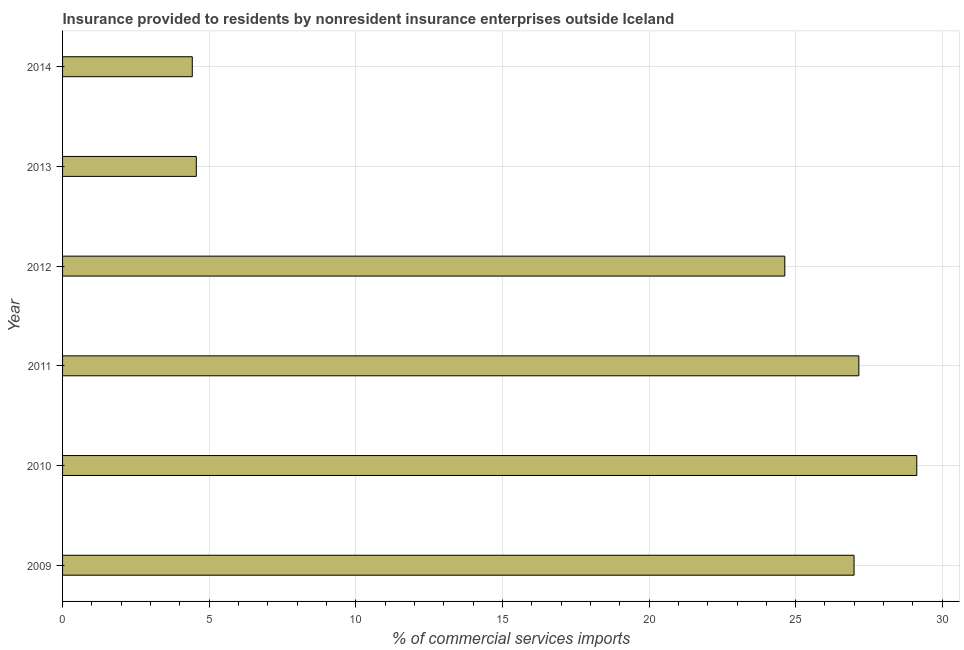What is the title of the graph?
Your response must be concise. Insurance provided to residents by nonresident insurance enterprises outside Iceland. What is the label or title of the X-axis?
Ensure brevity in your answer.  % of commercial services imports. What is the insurance provided by non-residents in 2010?
Offer a very short reply. 29.13. Across all years, what is the maximum insurance provided by non-residents?
Keep it short and to the point. 29.13. Across all years, what is the minimum insurance provided by non-residents?
Offer a very short reply. 4.42. In which year was the insurance provided by non-residents maximum?
Provide a succinct answer. 2010. In which year was the insurance provided by non-residents minimum?
Provide a short and direct response. 2014. What is the sum of the insurance provided by non-residents?
Your answer should be very brief. 116.89. What is the difference between the insurance provided by non-residents in 2013 and 2014?
Your response must be concise. 0.14. What is the average insurance provided by non-residents per year?
Ensure brevity in your answer.  19.48. What is the median insurance provided by non-residents?
Make the answer very short. 25.81. In how many years, is the insurance provided by non-residents greater than 13 %?
Your answer should be compact. 4. What is the ratio of the insurance provided by non-residents in 2009 to that in 2013?
Ensure brevity in your answer.  5.92. What is the difference between the highest and the second highest insurance provided by non-residents?
Provide a short and direct response. 1.98. Is the sum of the insurance provided by non-residents in 2012 and 2013 greater than the maximum insurance provided by non-residents across all years?
Provide a short and direct response. Yes. What is the difference between the highest and the lowest insurance provided by non-residents?
Give a very brief answer. 24.71. How many years are there in the graph?
Keep it short and to the point. 6. What is the difference between two consecutive major ticks on the X-axis?
Make the answer very short. 5. What is the % of commercial services imports of 2009?
Your answer should be very brief. 26.99. What is the % of commercial services imports of 2010?
Your response must be concise. 29.13. What is the % of commercial services imports in 2011?
Make the answer very short. 27.16. What is the % of commercial services imports of 2012?
Your answer should be very brief. 24.63. What is the % of commercial services imports in 2013?
Offer a very short reply. 4.56. What is the % of commercial services imports of 2014?
Offer a very short reply. 4.42. What is the difference between the % of commercial services imports in 2009 and 2010?
Your response must be concise. -2.14. What is the difference between the % of commercial services imports in 2009 and 2011?
Give a very brief answer. -0.16. What is the difference between the % of commercial services imports in 2009 and 2012?
Your answer should be compact. 2.36. What is the difference between the % of commercial services imports in 2009 and 2013?
Offer a terse response. 22.43. What is the difference between the % of commercial services imports in 2009 and 2014?
Provide a succinct answer. 22.57. What is the difference between the % of commercial services imports in 2010 and 2011?
Offer a very short reply. 1.98. What is the difference between the % of commercial services imports in 2010 and 2012?
Offer a terse response. 4.5. What is the difference between the % of commercial services imports in 2010 and 2013?
Give a very brief answer. 24.57. What is the difference between the % of commercial services imports in 2010 and 2014?
Give a very brief answer. 24.71. What is the difference between the % of commercial services imports in 2011 and 2012?
Offer a terse response. 2.53. What is the difference between the % of commercial services imports in 2011 and 2013?
Your answer should be compact. 22.59. What is the difference between the % of commercial services imports in 2011 and 2014?
Offer a terse response. 22.73. What is the difference between the % of commercial services imports in 2012 and 2013?
Your answer should be compact. 20.07. What is the difference between the % of commercial services imports in 2012 and 2014?
Offer a terse response. 20.21. What is the difference between the % of commercial services imports in 2013 and 2014?
Your answer should be very brief. 0.14. What is the ratio of the % of commercial services imports in 2009 to that in 2010?
Offer a terse response. 0.93. What is the ratio of the % of commercial services imports in 2009 to that in 2012?
Give a very brief answer. 1.1. What is the ratio of the % of commercial services imports in 2009 to that in 2013?
Your response must be concise. 5.92. What is the ratio of the % of commercial services imports in 2009 to that in 2014?
Your answer should be compact. 6.1. What is the ratio of the % of commercial services imports in 2010 to that in 2011?
Your response must be concise. 1.07. What is the ratio of the % of commercial services imports in 2010 to that in 2012?
Make the answer very short. 1.18. What is the ratio of the % of commercial services imports in 2010 to that in 2013?
Offer a very short reply. 6.39. What is the ratio of the % of commercial services imports in 2010 to that in 2014?
Your answer should be compact. 6.58. What is the ratio of the % of commercial services imports in 2011 to that in 2012?
Your answer should be compact. 1.1. What is the ratio of the % of commercial services imports in 2011 to that in 2013?
Offer a terse response. 5.95. What is the ratio of the % of commercial services imports in 2011 to that in 2014?
Provide a succinct answer. 6.14. What is the ratio of the % of commercial services imports in 2012 to that in 2014?
Keep it short and to the point. 5.57. What is the ratio of the % of commercial services imports in 2013 to that in 2014?
Give a very brief answer. 1.03. 